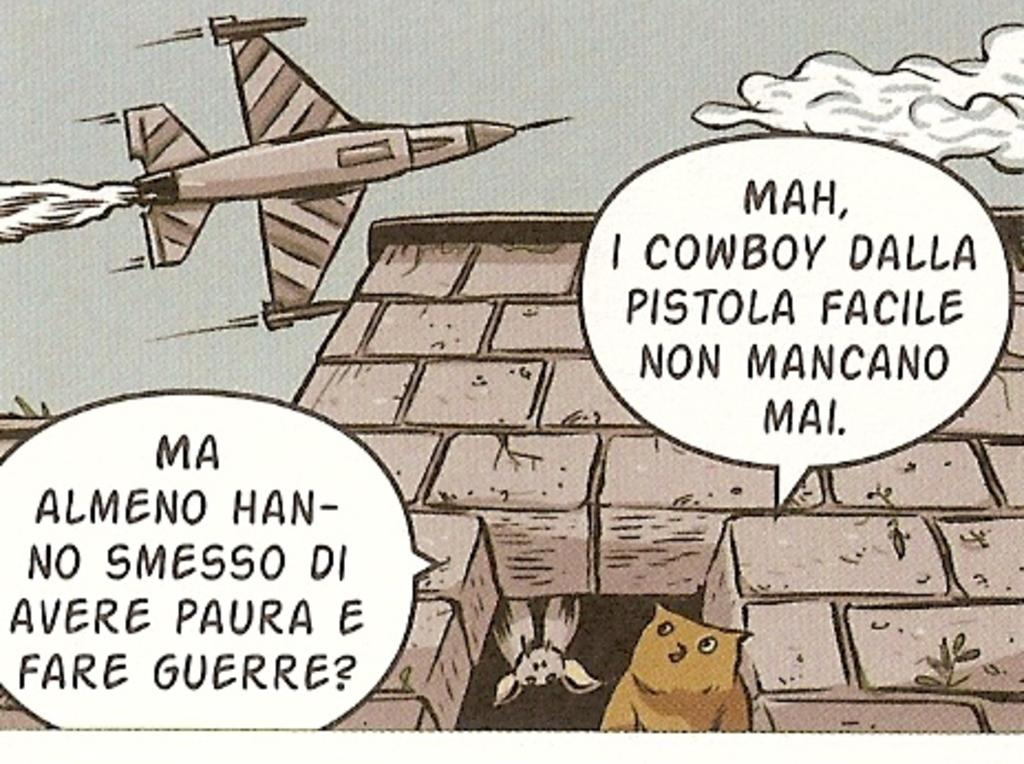What type of structure is depicted in the image? The image contains an animated building. Are there any living creatures inside the building? Yes, there are two birds in the building. What can be seen in the sky in the image? There is an aircraft visible in the sky. Is there any text present in the image? Yes, there is text present in the image. What type of brain is being offered by the kitty in the image? There is no kitty or brain present in the image. 